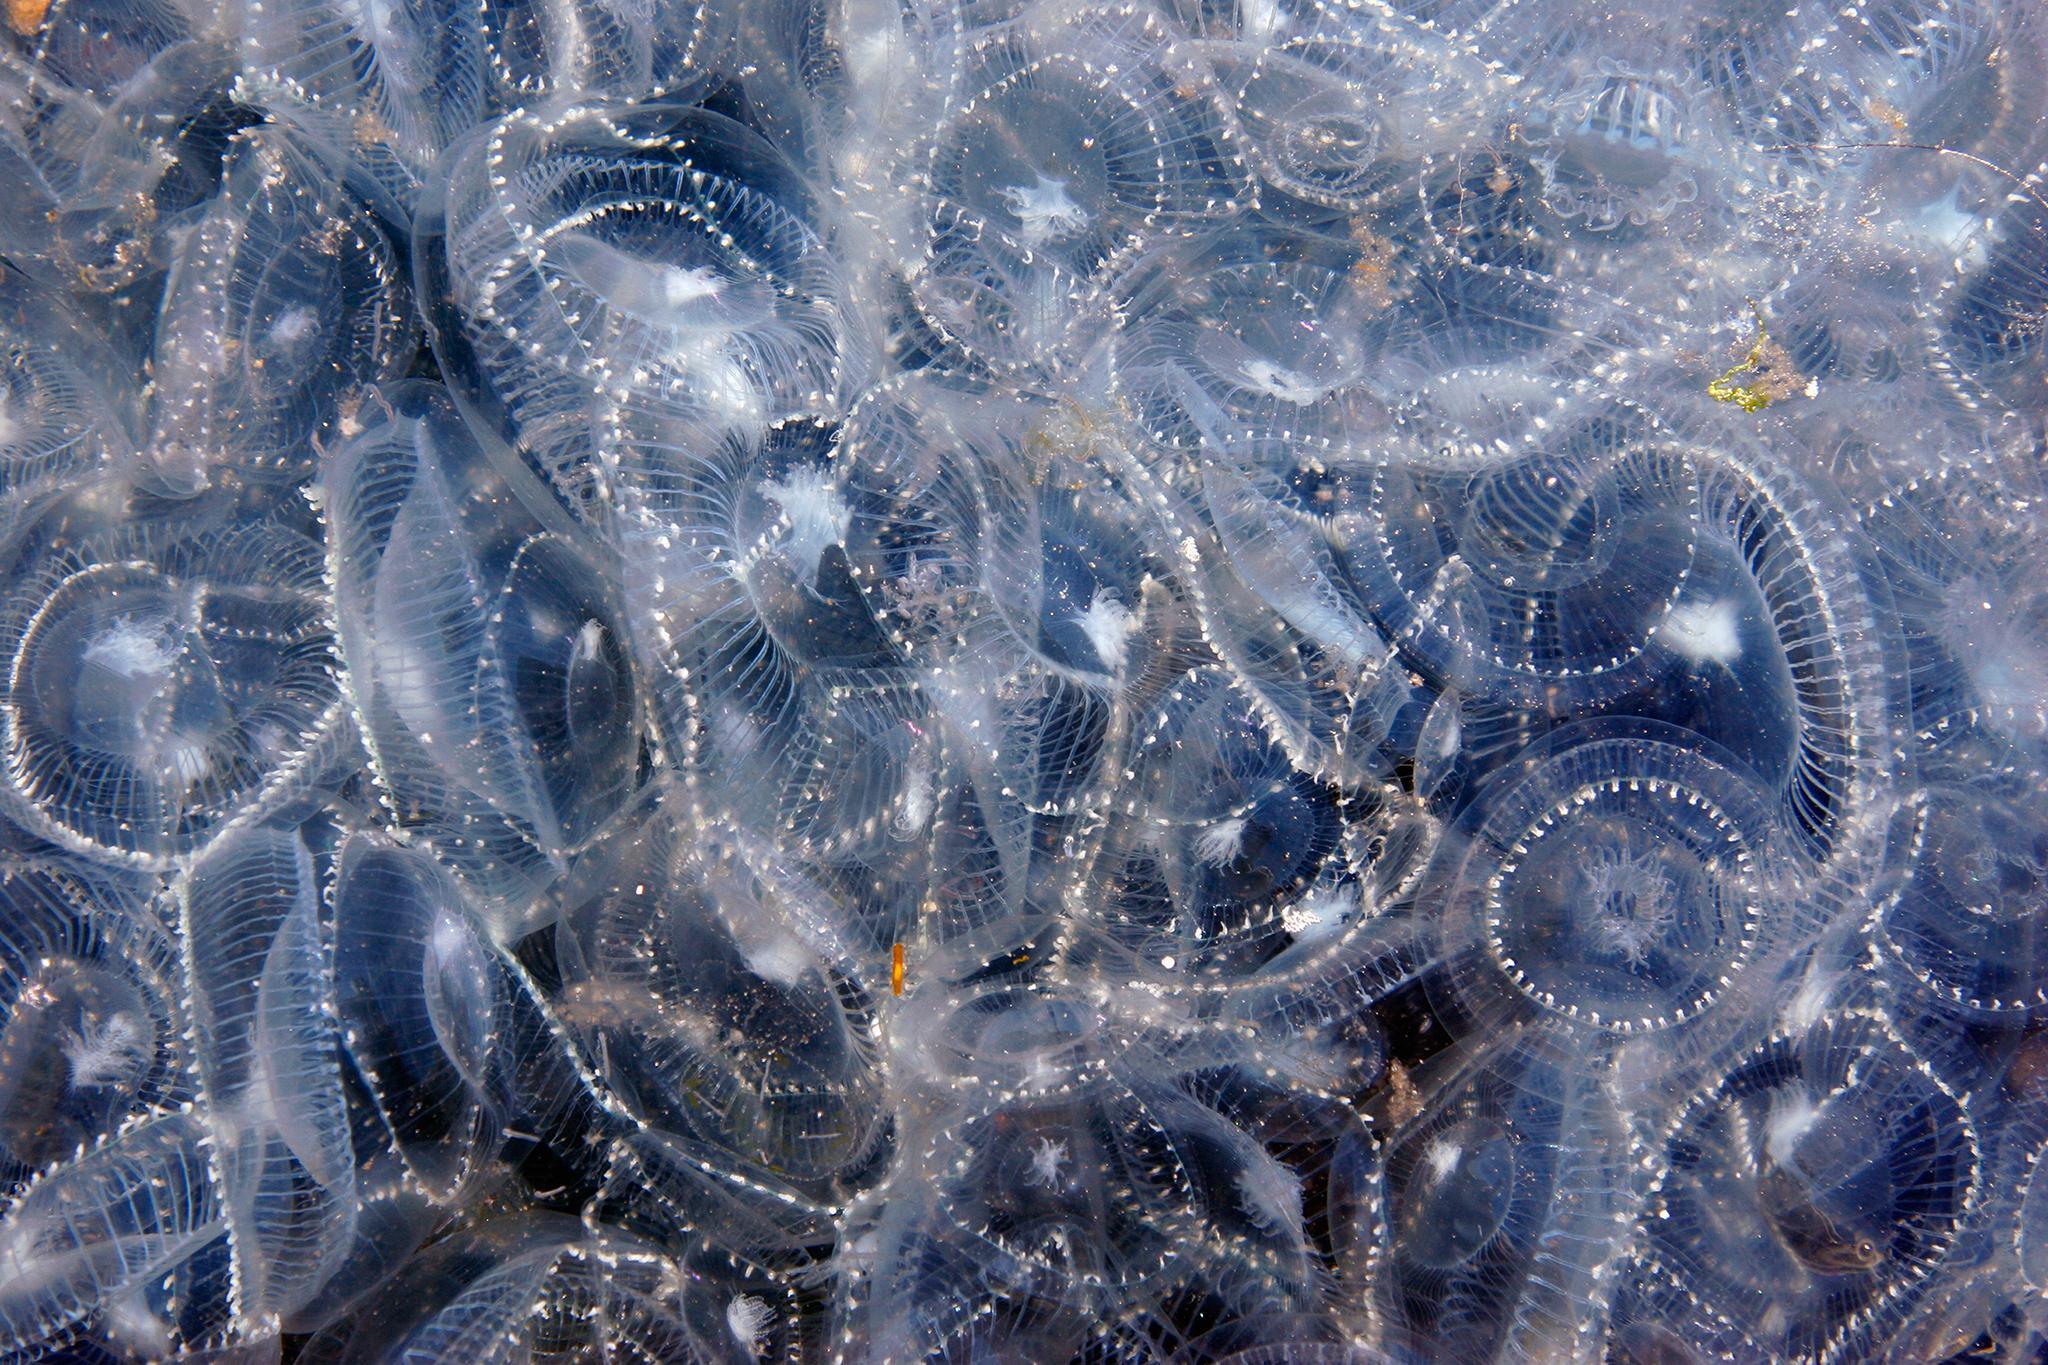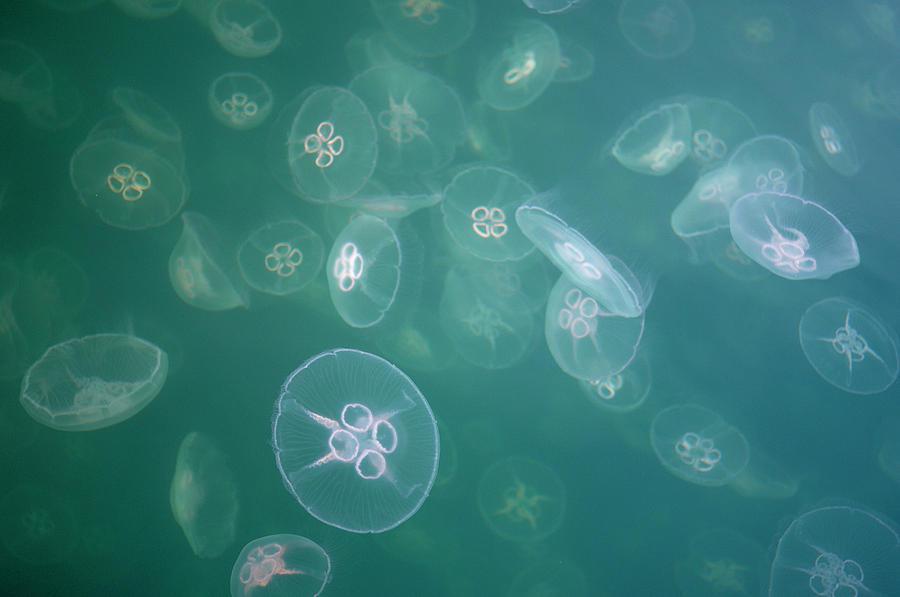The first image is the image on the left, the second image is the image on the right. Assess this claim about the two images: "The left image shows masses of light blue jellyfish viewed from above the water's surface, with a city horizon in the background.". Correct or not? Answer yes or no. No. The first image is the image on the left, the second image is the image on the right. Considering the images on both sides, is "there are many jellyfish being viewed from above water in daylight hours" valid? Answer yes or no. No. 